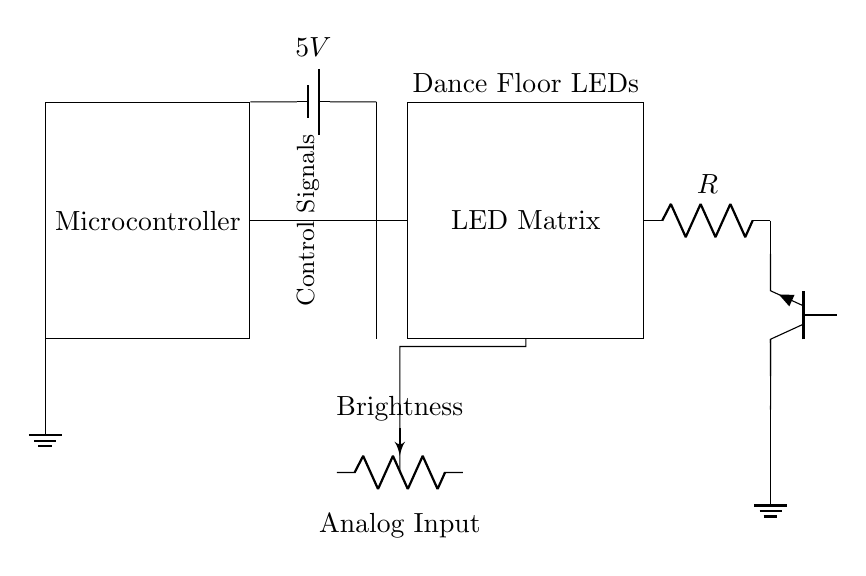What type of microcontroller is shown in the circuit? The circuit does not specify a particular type but shows a generic microcontroller symbol.
Answer: Microcontroller What is the purpose of the potentiometer labeled "Brightness"? The potentiometer is used to adjust the brightness of the LED matrix, allowing for manual control of the LED intensity.
Answer: Brightness control What is the function of the resistor labeled "R"? The resistor limits the current flowing to the LED matrix to prevent damage from excessive current.
Answer: Current limiting How many main components are connected to the microcontroller? The main components connected to the microcontroller are the LED matrix and the transistor, indicated by the connections shown.
Answer: Two What happens if the potentiometer is adjusted to its maximum value? Adjusting the potentiometer to its maximum value would allow the maximum voltage to the LED matrix, increasing their brightness significantly.
Answer: Maximum brightness What type of transistor is used in this circuit? The circuit depicts an NPN transistor as indicated by the label next to the triangle symbol.
Answer: NPN 